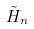<formula> <loc_0><loc_0><loc_500><loc_500>\tilde { H } _ { n }</formula> 